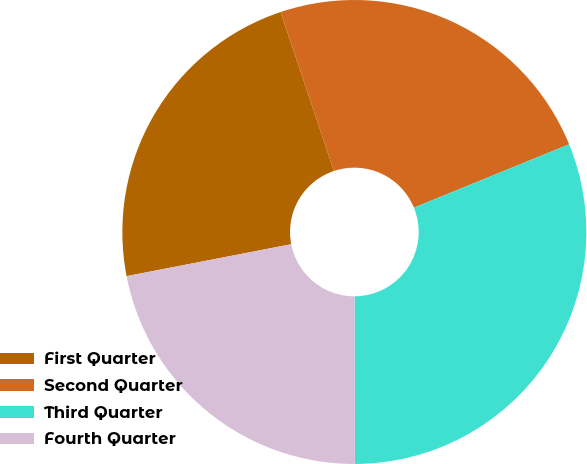Convert chart to OTSL. <chart><loc_0><loc_0><loc_500><loc_500><pie_chart><fcel>First Quarter<fcel>Second Quarter<fcel>Third Quarter<fcel>Fourth Quarter<nl><fcel>22.9%<fcel>23.98%<fcel>31.13%<fcel>21.99%<nl></chart> 